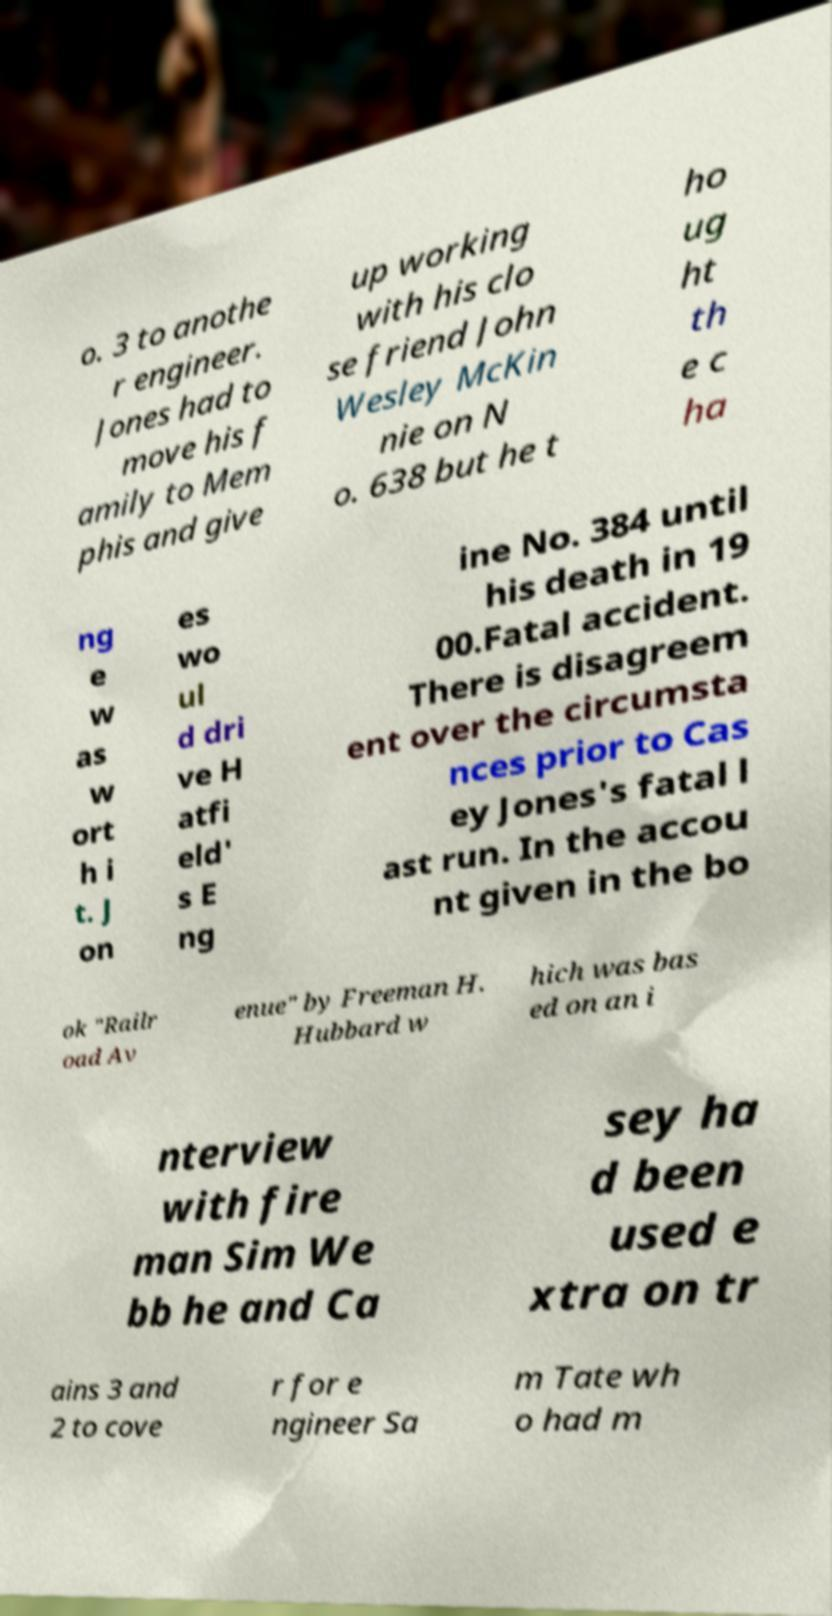What messages or text are displayed in this image? I need them in a readable, typed format. o. 3 to anothe r engineer. Jones had to move his f amily to Mem phis and give up working with his clo se friend John Wesley McKin nie on N o. 638 but he t ho ug ht th e c ha ng e w as w ort h i t. J on es wo ul d dri ve H atfi eld' s E ng ine No. 384 until his death in 19 00.Fatal accident. There is disagreem ent over the circumsta nces prior to Cas ey Jones's fatal l ast run. In the accou nt given in the bo ok "Railr oad Av enue" by Freeman H. Hubbard w hich was bas ed on an i nterview with fire man Sim We bb he and Ca sey ha d been used e xtra on tr ains 3 and 2 to cove r for e ngineer Sa m Tate wh o had m 